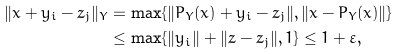<formula> <loc_0><loc_0><loc_500><loc_500>\| x + y _ { i } - z _ { j } \| _ { Y } & = \max \{ \| P _ { Y } ( x ) + y _ { i } - z _ { j } \| , \| x - P _ { Y } ( x ) \| \} \\ & \leq \max \{ \| y _ { i } \| + \| z - z _ { j } \| , 1 \} \leq 1 + \varepsilon ,</formula> 